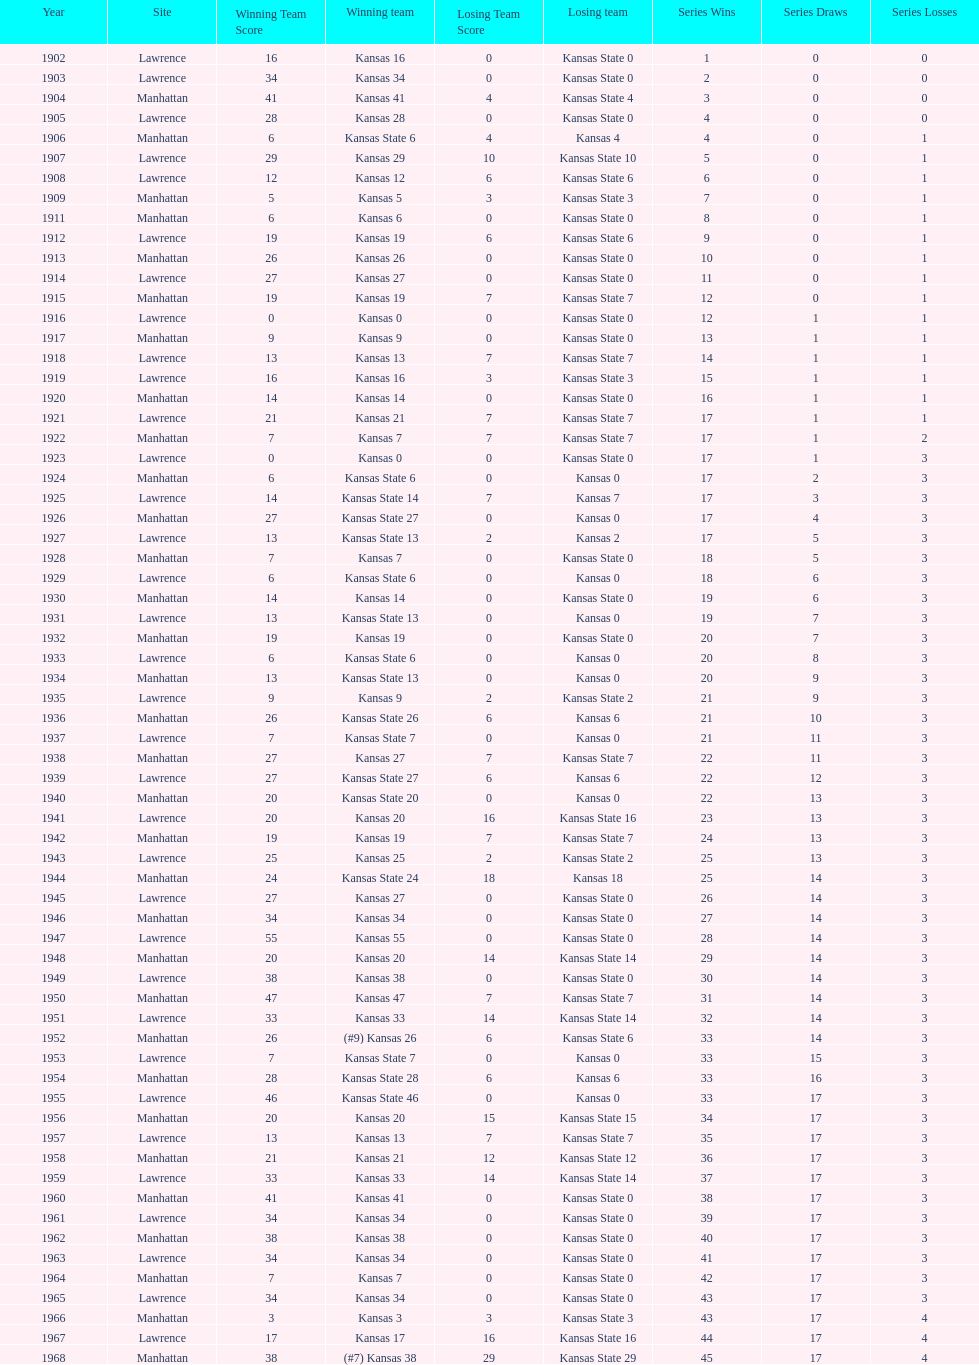What was the number of wins kansas state had in manhattan? 8. 